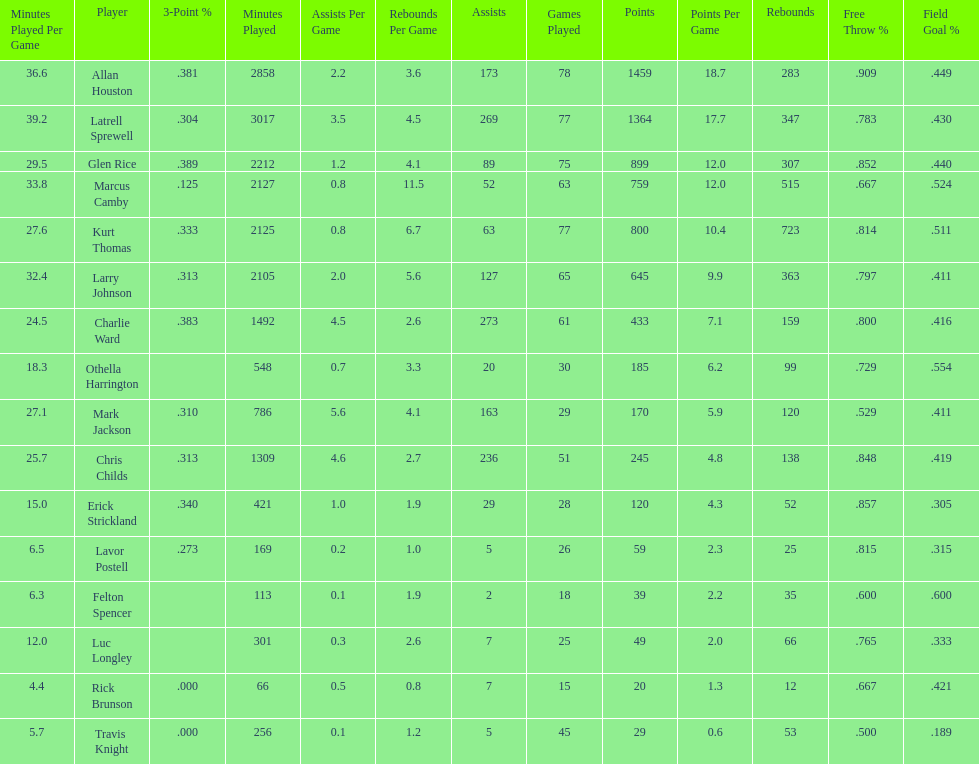How many more games did allan houston play than mark jackson? 49. 